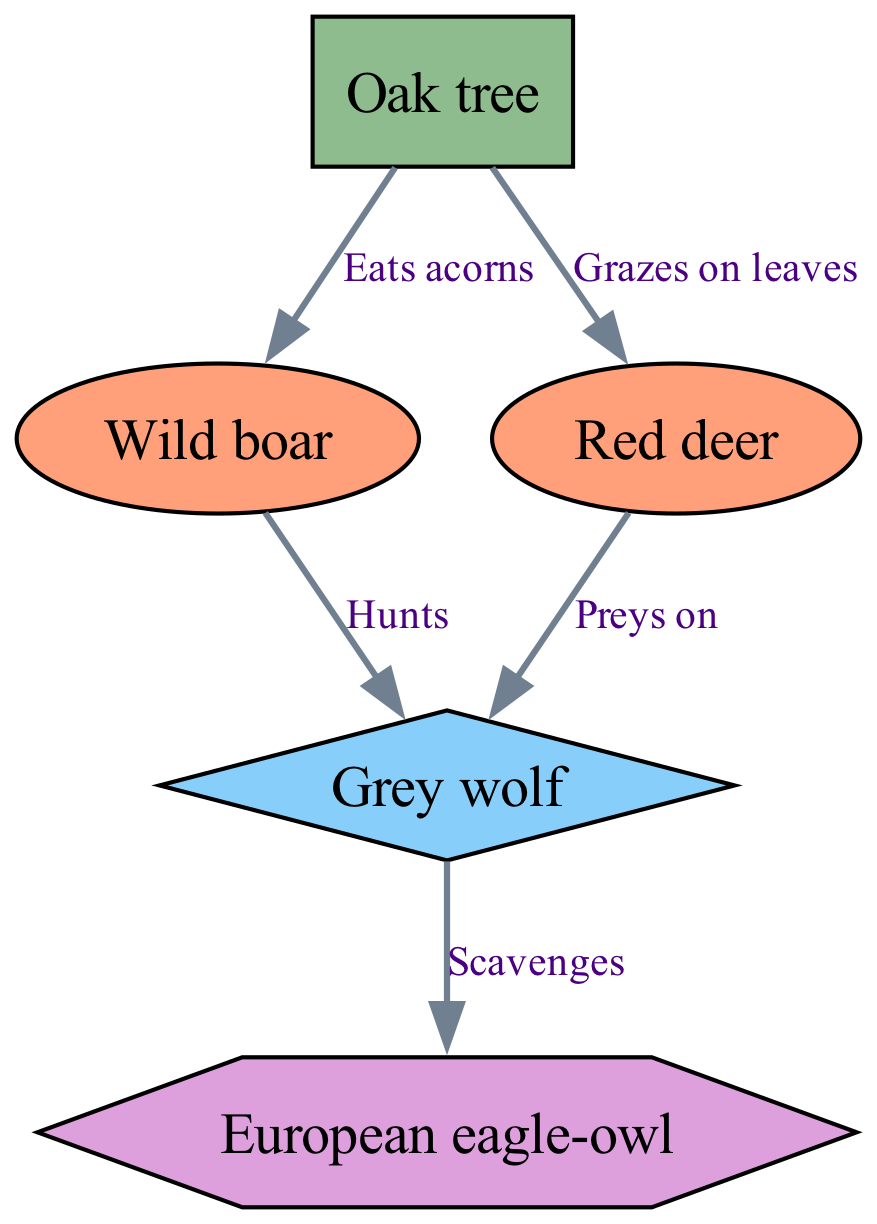What is the total number of organisms shown in the diagram? The diagram lists five organisms: Oak tree, Wild boar, Red deer, Grey wolf, and European eagle-owl. By counting each unique organism, we confirm that there are indeed five.
Answer: 5 What type of consumer is the Grey wolf? In the diagram, the Grey wolf is categorized as a Secondary consumer. This classification is clearly indicated by the type label assigned to the organism.
Answer: Secondary consumer What does the Wild boar eat? According to the relationship shown in the diagram, the Wild boar eats acorns from the Oak tree. This direct relationship is explicitly stated with the label indicating what it consumes.
Answer: Acorns Which organism is at the top of the food chain? The European eagle-owl is depicted as the Tertiary consumer in the diagram, indicating it sits at the top of this food chain as a predator that scavenges on other organisms.
Answer: European eagle-owl How many primary consumers are present in the diagram? The diagram indicates there are two primary consumers: the Wild boar and the Red deer. By identifying and counting these two organisms, we determine the total number of primary consumers.
Answer: 2 Who scavenges on the Grey wolf? The diagram shows that the European eagle-owl scavenges on the Grey wolf, which is specified by the relationship indicated between these two organisms.
Answer: European eagle-owl What do Red deer graze on? In the diagram, it is indicated that Red deer graze on the leaves of the Oak tree. This relationship highlights the direct interaction between these two organisms.
Answer: Leaves Which organism preys on the Red deer? The Grey wolf is shown in the diagram to prey on the Red deer, which is depicted in the relationships to illustrate this predatory behavior.
Answer: Grey wolf What is the relationship between the Oak tree and Wild boar? The relationship labeled "Eats acorns" signifies that the Wild boar's interaction with the Oak tree involves consumption of its acorns.
Answer: Eats acorns 